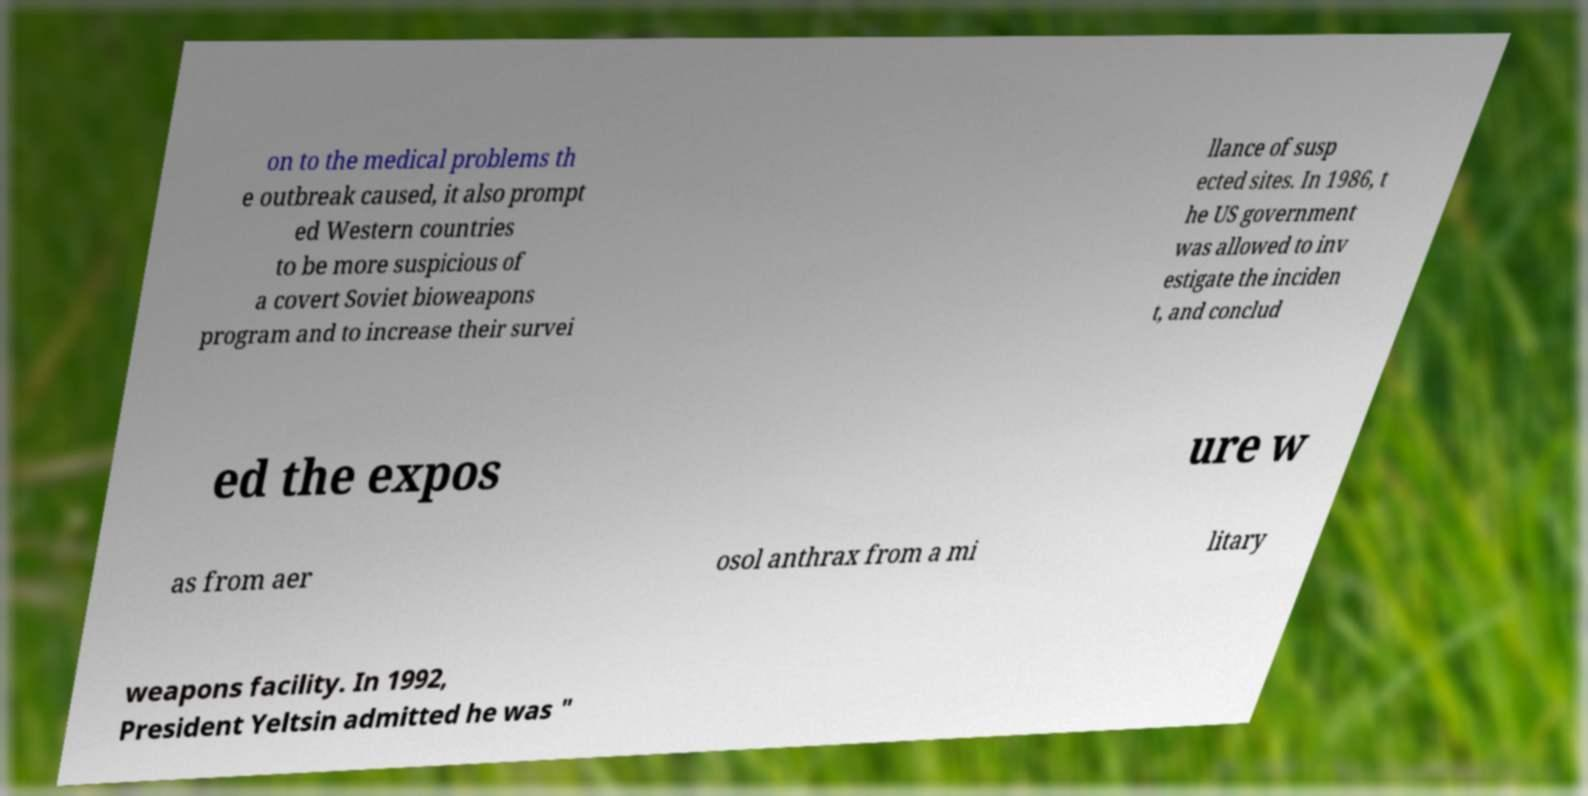Can you read and provide the text displayed in the image?This photo seems to have some interesting text. Can you extract and type it out for me? on to the medical problems th e outbreak caused, it also prompt ed Western countries to be more suspicious of a covert Soviet bioweapons program and to increase their survei llance of susp ected sites. In 1986, t he US government was allowed to inv estigate the inciden t, and conclud ed the expos ure w as from aer osol anthrax from a mi litary weapons facility. In 1992, President Yeltsin admitted he was " 